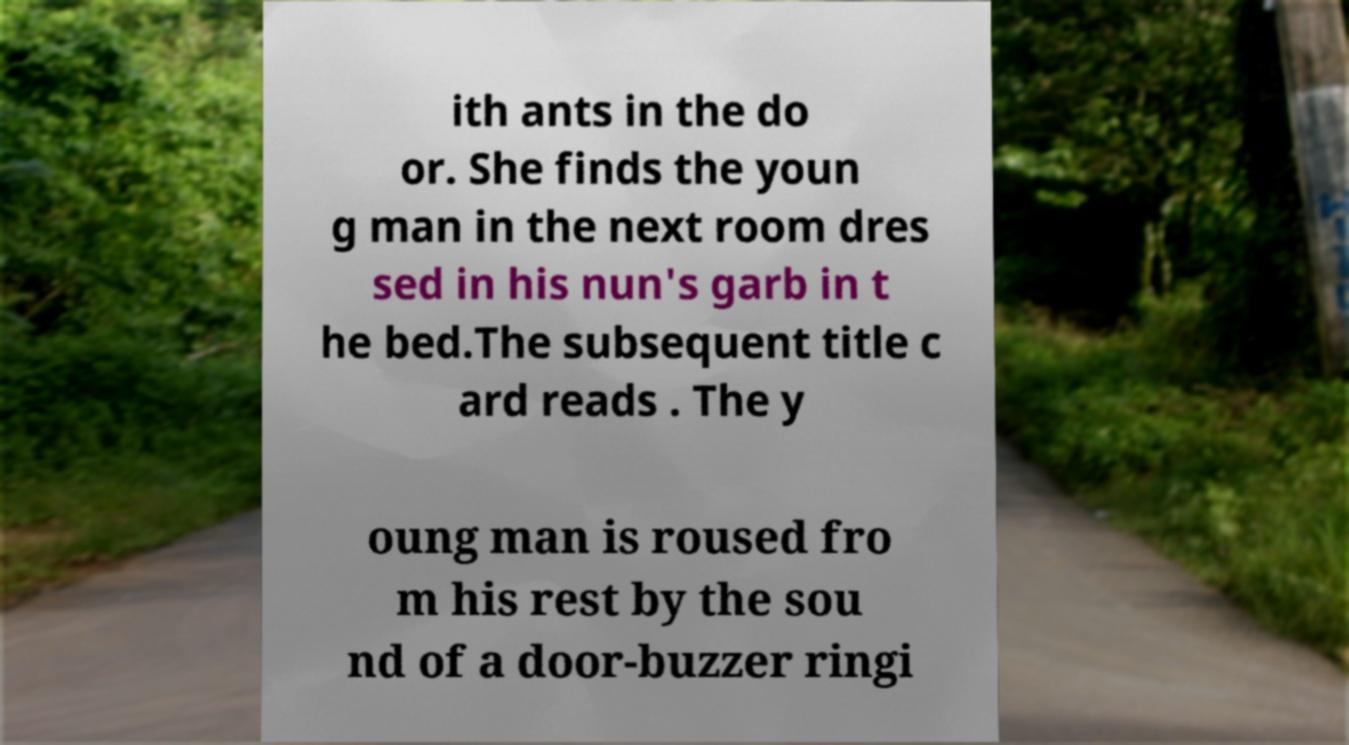Can you read and provide the text displayed in the image?This photo seems to have some interesting text. Can you extract and type it out for me? ith ants in the do or. She finds the youn g man in the next room dres sed in his nun's garb in t he bed.The subsequent title c ard reads . The y oung man is roused fro m his rest by the sou nd of a door-buzzer ringi 